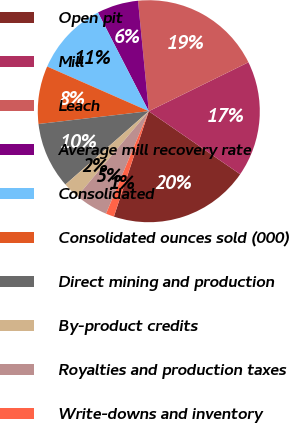<chart> <loc_0><loc_0><loc_500><loc_500><pie_chart><fcel>Open pit<fcel>Mill<fcel>Leach<fcel>Average mill recovery rate<fcel>Consolidated<fcel>Consolidated ounces sold (000)<fcel>Direct mining and production<fcel>By-product credits<fcel>Royalties and production taxes<fcel>Write-downs and inventory<nl><fcel>20.48%<fcel>16.87%<fcel>19.28%<fcel>6.02%<fcel>10.84%<fcel>8.43%<fcel>9.64%<fcel>2.41%<fcel>4.82%<fcel>1.2%<nl></chart> 